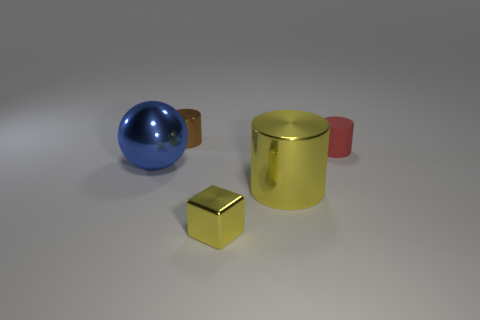Subtract all purple cylinders. Subtract all cyan balls. How many cylinders are left? 3 Add 3 small yellow matte cylinders. How many objects exist? 8 Subtract all blocks. How many objects are left? 4 Add 2 small red rubber things. How many small red rubber things exist? 3 Subtract 0 red blocks. How many objects are left? 5 Subtract all tiny purple shiny blocks. Subtract all small red rubber things. How many objects are left? 4 Add 5 big blue balls. How many big blue balls are left? 6 